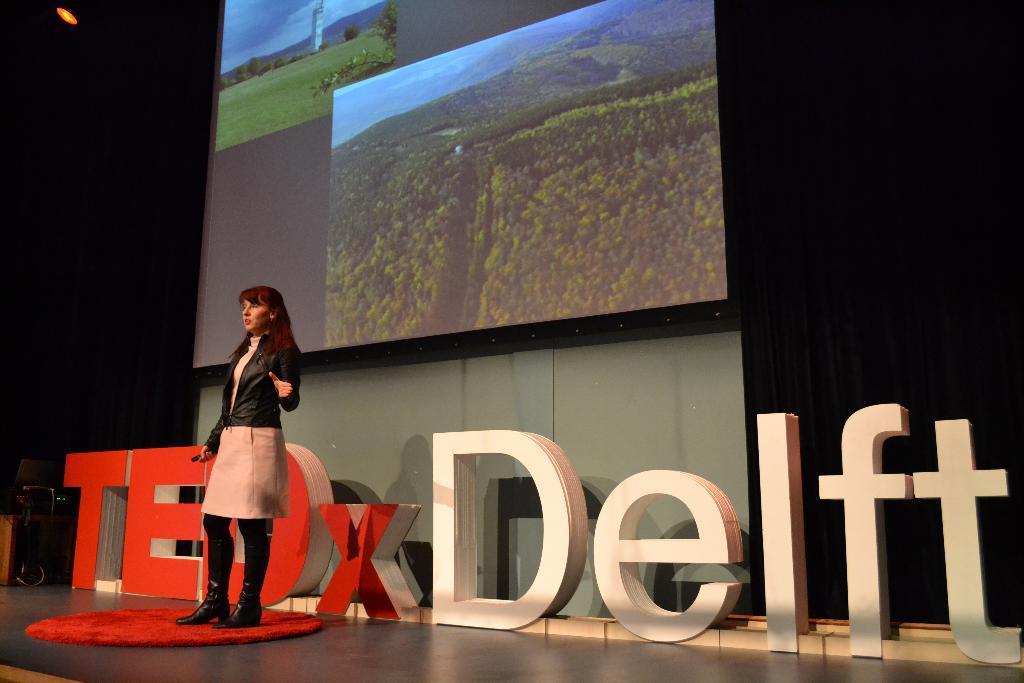Please provide a concise description of this image. In this image there is one women standing at left side of this image is wearing black color jacket and there is a screen at top of this image and there is a wall in the background and there is an object with text at bottom of this image. 